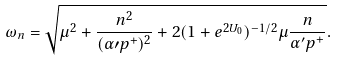<formula> <loc_0><loc_0><loc_500><loc_500>\omega _ { n } = \sqrt { \mu ^ { 2 } + \frac { n ^ { 2 } } { ( \alpha \prime p ^ { + } ) ^ { 2 } } + 2 ( 1 + e ^ { 2 U _ { 0 } } ) ^ { - 1 / 2 } \mu \frac { n } { \alpha ^ { \prime } p ^ { + } } } .</formula> 